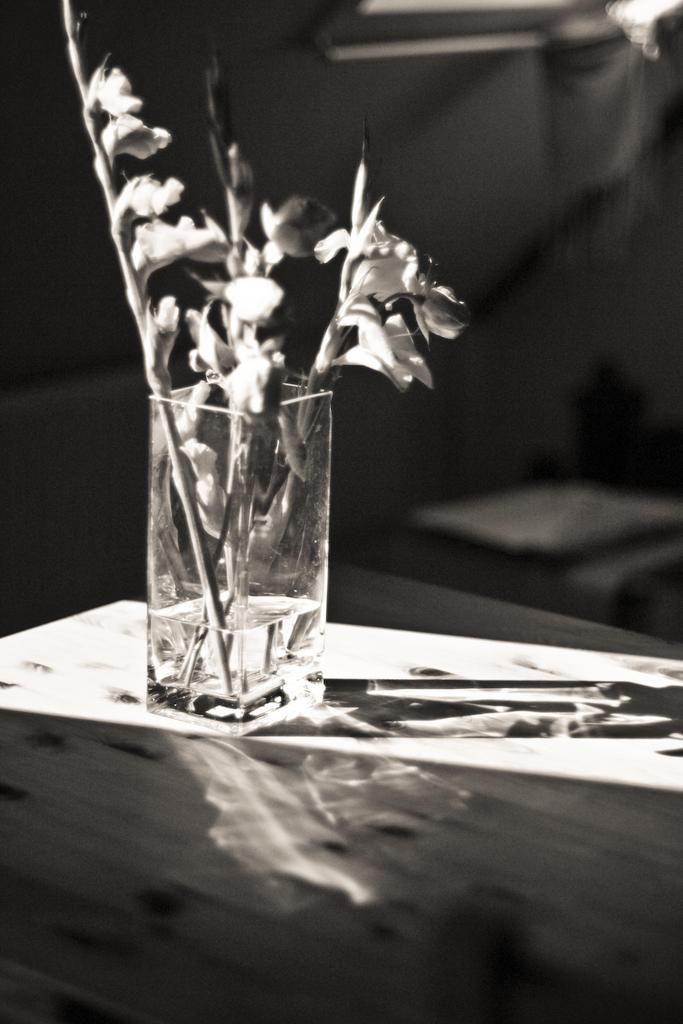What is the color scheme of the image? The image is black and white. What type of flora can be seen in the image? There are flowers in the image. How much water is in the glass visible in the image? The glass has less than half water in it. Where is the glass located in the image? The glass is on a platform. What can be seen in the background of the image? There are objects in the background of the image. What type of cable is being used for work in the image? There is no cable or work-related activity present in the image. What facial expression can be seen on the flowers in the image? Flowers do not have facial expressions, as they are inanimate objects. 